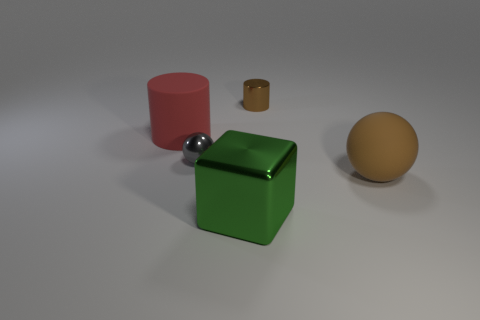Add 2 brown rubber cylinders. How many objects exist? 7 Subtract all balls. How many objects are left? 3 Subtract 0 gray cylinders. How many objects are left? 5 Subtract all brown rubber balls. Subtract all red rubber things. How many objects are left? 3 Add 5 gray balls. How many gray balls are left? 6 Add 2 tiny brown metal things. How many tiny brown metal things exist? 3 